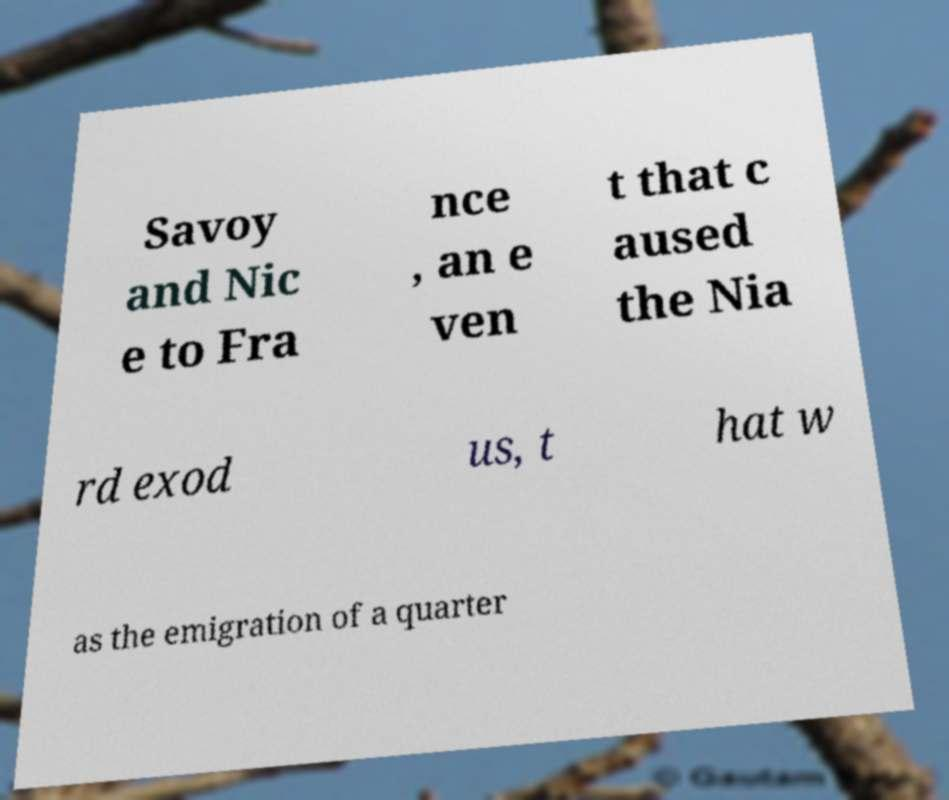There's text embedded in this image that I need extracted. Can you transcribe it verbatim? Savoy and Nic e to Fra nce , an e ven t that c aused the Nia rd exod us, t hat w as the emigration of a quarter 